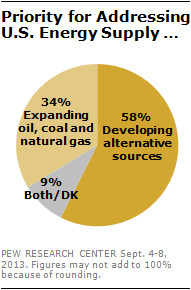Highlight a few significant elements in this photo. The pie chart is divided into three parts. The sum of the two lowest values in the pie chart is 43. 